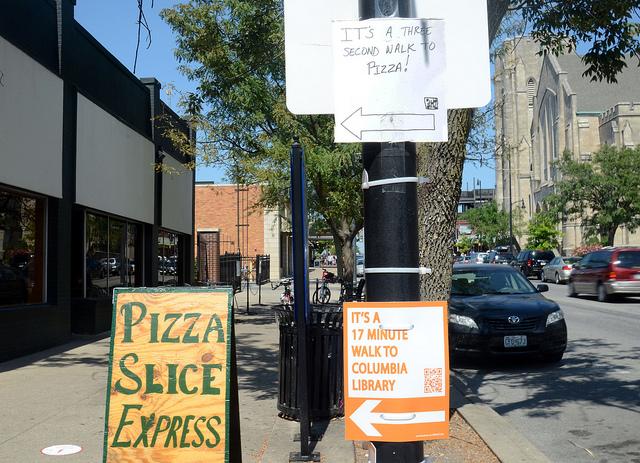How many minutes will it take to walk to Columbia library?
Quick response, please. 17. What is been advertised?
Be succinct. Pizza. What color is the building on the right?
Keep it brief. Gray. 